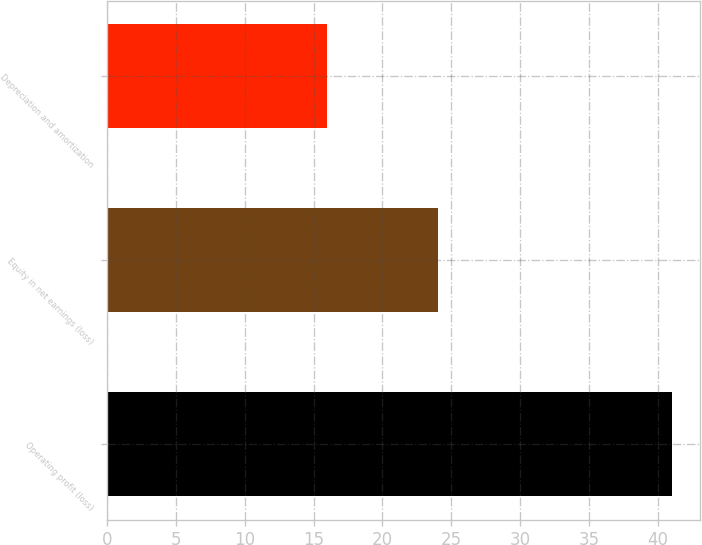Convert chart. <chart><loc_0><loc_0><loc_500><loc_500><bar_chart><fcel>Operating profit (loss)<fcel>Equity in net earnings (loss)<fcel>Depreciation and amortization<nl><fcel>41<fcel>24<fcel>16<nl></chart> 